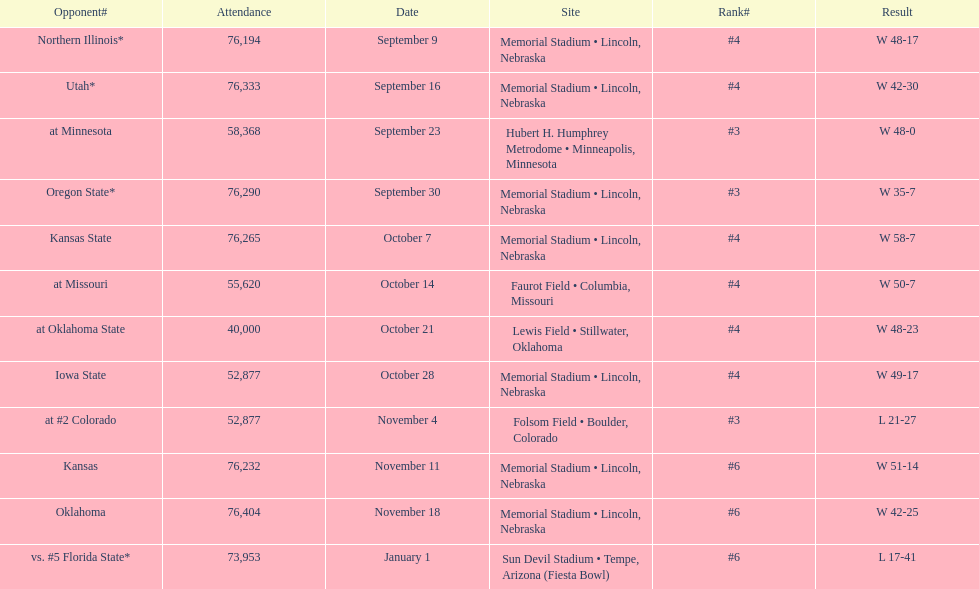How many games did they win by more than 7? 10. 